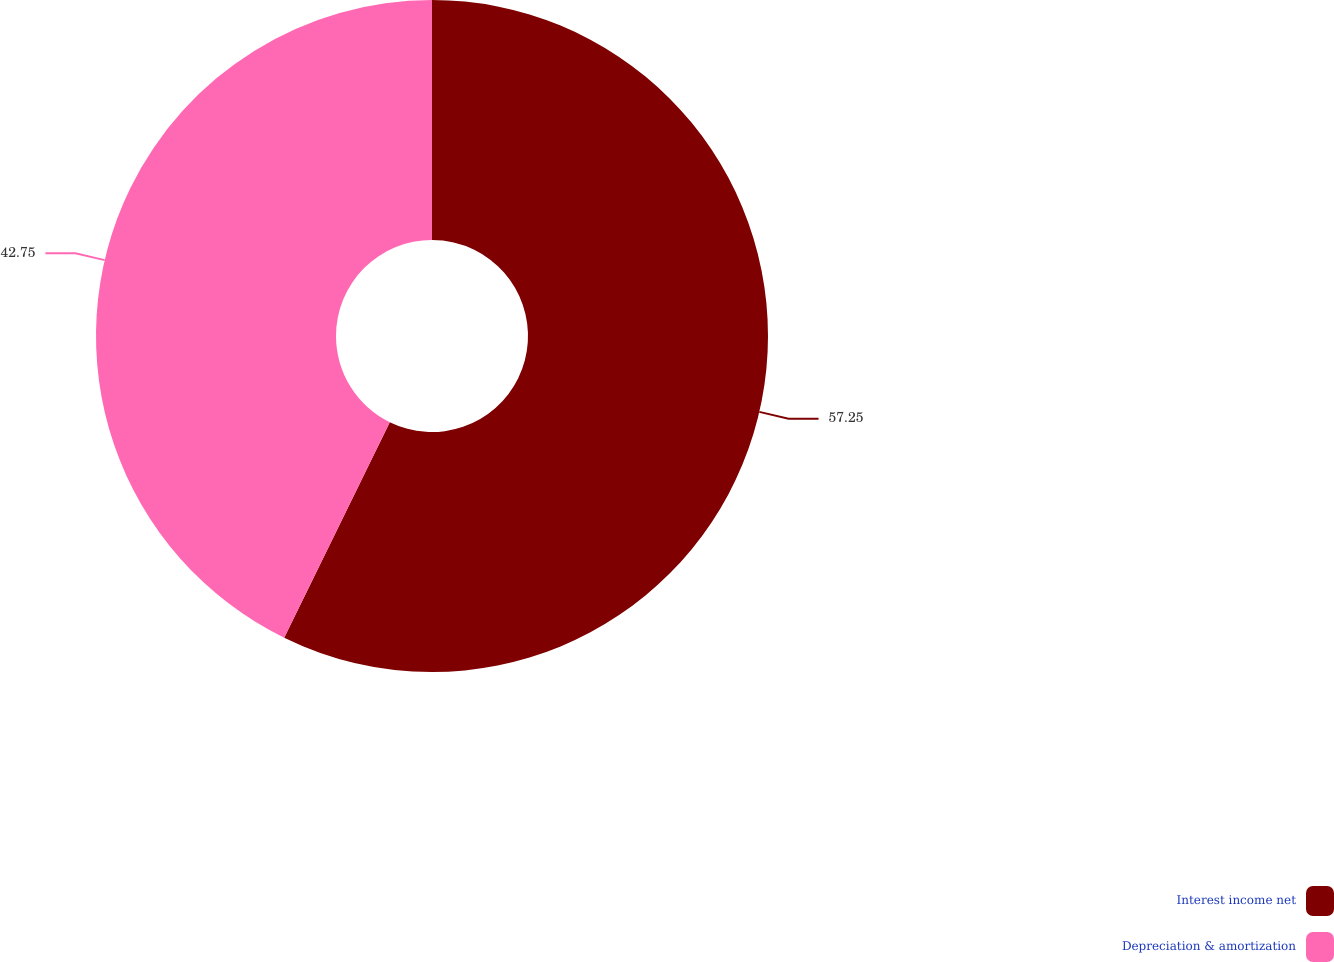<chart> <loc_0><loc_0><loc_500><loc_500><pie_chart><fcel>Interest income net<fcel>Depreciation & amortization<nl><fcel>57.25%<fcel>42.75%<nl></chart> 